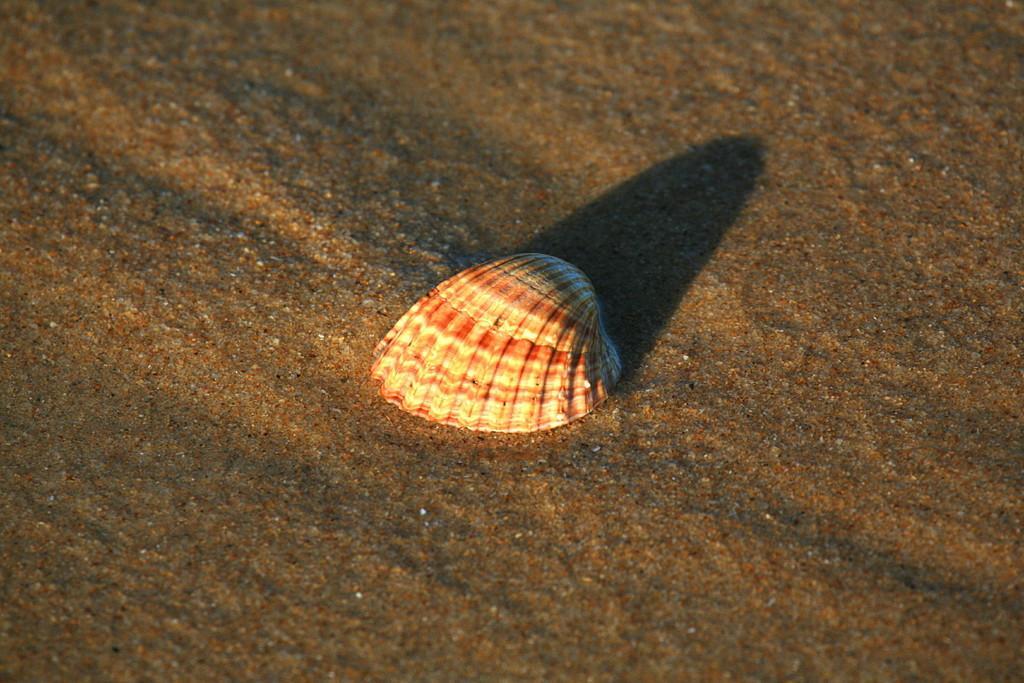How would you summarize this image in a sentence or two? In the picture we can see a sand which is wet on it, we can see a shell which is white in color with some red color shades on it. 